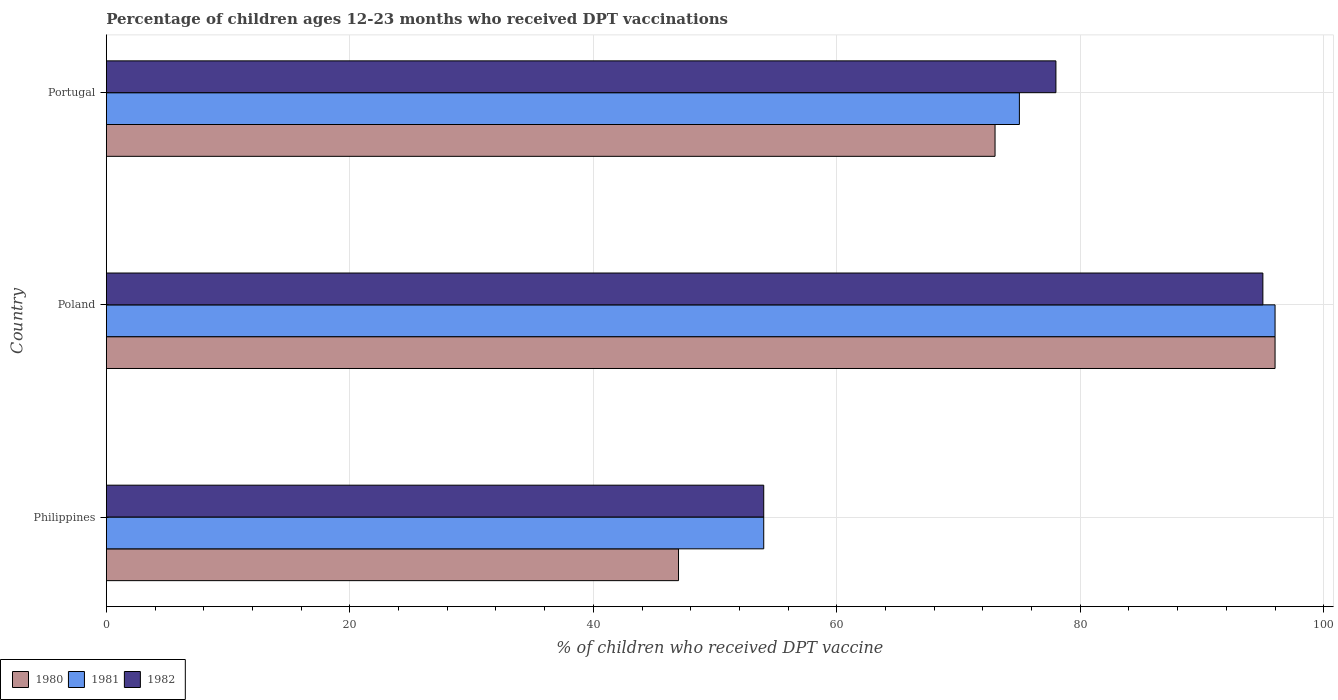Are the number of bars on each tick of the Y-axis equal?
Your answer should be compact. Yes. How many bars are there on the 3rd tick from the top?
Keep it short and to the point. 3. What is the label of the 2nd group of bars from the top?
Your answer should be compact. Poland. What is the percentage of children who received DPT vaccination in 1981 in Philippines?
Your answer should be compact. 54. Across all countries, what is the maximum percentage of children who received DPT vaccination in 1981?
Ensure brevity in your answer.  96. In which country was the percentage of children who received DPT vaccination in 1981 maximum?
Your response must be concise. Poland. In which country was the percentage of children who received DPT vaccination in 1980 minimum?
Ensure brevity in your answer.  Philippines. What is the total percentage of children who received DPT vaccination in 1980 in the graph?
Offer a very short reply. 216. What is the difference between the percentage of children who received DPT vaccination in 1980 in Philippines and that in Poland?
Keep it short and to the point. -49. What is the difference between the percentage of children who received DPT vaccination in 1980 in Poland and the percentage of children who received DPT vaccination in 1981 in Portugal?
Ensure brevity in your answer.  21. What is the difference between the percentage of children who received DPT vaccination in 1980 and percentage of children who received DPT vaccination in 1981 in Philippines?
Offer a very short reply. -7. What is the ratio of the percentage of children who received DPT vaccination in 1980 in Philippines to that in Poland?
Your response must be concise. 0.49. What is the difference between the highest and the lowest percentage of children who received DPT vaccination in 1982?
Provide a short and direct response. 41. Is the sum of the percentage of children who received DPT vaccination in 1982 in Philippines and Portugal greater than the maximum percentage of children who received DPT vaccination in 1980 across all countries?
Offer a very short reply. Yes. Is it the case that in every country, the sum of the percentage of children who received DPT vaccination in 1981 and percentage of children who received DPT vaccination in 1982 is greater than the percentage of children who received DPT vaccination in 1980?
Offer a terse response. Yes. How many countries are there in the graph?
Provide a short and direct response. 3. Are the values on the major ticks of X-axis written in scientific E-notation?
Your answer should be very brief. No. How are the legend labels stacked?
Offer a very short reply. Horizontal. What is the title of the graph?
Ensure brevity in your answer.  Percentage of children ages 12-23 months who received DPT vaccinations. What is the label or title of the X-axis?
Your answer should be compact. % of children who received DPT vaccine. What is the label or title of the Y-axis?
Offer a terse response. Country. What is the % of children who received DPT vaccine of 1980 in Philippines?
Offer a very short reply. 47. What is the % of children who received DPT vaccine in 1982 in Philippines?
Offer a terse response. 54. What is the % of children who received DPT vaccine of 1980 in Poland?
Make the answer very short. 96. What is the % of children who received DPT vaccine of 1981 in Poland?
Your answer should be very brief. 96. What is the % of children who received DPT vaccine in 1980 in Portugal?
Your response must be concise. 73. What is the % of children who received DPT vaccine in 1981 in Portugal?
Ensure brevity in your answer.  75. What is the % of children who received DPT vaccine in 1982 in Portugal?
Your answer should be very brief. 78. Across all countries, what is the maximum % of children who received DPT vaccine of 1980?
Offer a very short reply. 96. Across all countries, what is the maximum % of children who received DPT vaccine of 1981?
Your answer should be compact. 96. Across all countries, what is the maximum % of children who received DPT vaccine of 1982?
Your response must be concise. 95. Across all countries, what is the minimum % of children who received DPT vaccine in 1980?
Make the answer very short. 47. Across all countries, what is the minimum % of children who received DPT vaccine in 1981?
Keep it short and to the point. 54. Across all countries, what is the minimum % of children who received DPT vaccine in 1982?
Ensure brevity in your answer.  54. What is the total % of children who received DPT vaccine in 1980 in the graph?
Your response must be concise. 216. What is the total % of children who received DPT vaccine in 1981 in the graph?
Provide a short and direct response. 225. What is the total % of children who received DPT vaccine in 1982 in the graph?
Offer a terse response. 227. What is the difference between the % of children who received DPT vaccine in 1980 in Philippines and that in Poland?
Provide a succinct answer. -49. What is the difference between the % of children who received DPT vaccine of 1981 in Philippines and that in Poland?
Provide a succinct answer. -42. What is the difference between the % of children who received DPT vaccine of 1982 in Philippines and that in Poland?
Your answer should be compact. -41. What is the difference between the % of children who received DPT vaccine of 1980 in Poland and that in Portugal?
Make the answer very short. 23. What is the difference between the % of children who received DPT vaccine of 1981 in Poland and that in Portugal?
Keep it short and to the point. 21. What is the difference between the % of children who received DPT vaccine of 1980 in Philippines and the % of children who received DPT vaccine of 1981 in Poland?
Provide a succinct answer. -49. What is the difference between the % of children who received DPT vaccine in 1980 in Philippines and the % of children who received DPT vaccine in 1982 in Poland?
Provide a succinct answer. -48. What is the difference between the % of children who received DPT vaccine of 1981 in Philippines and the % of children who received DPT vaccine of 1982 in Poland?
Offer a very short reply. -41. What is the difference between the % of children who received DPT vaccine of 1980 in Philippines and the % of children who received DPT vaccine of 1982 in Portugal?
Provide a succinct answer. -31. What is the difference between the % of children who received DPT vaccine of 1980 in Poland and the % of children who received DPT vaccine of 1982 in Portugal?
Your response must be concise. 18. What is the average % of children who received DPT vaccine in 1982 per country?
Provide a succinct answer. 75.67. What is the difference between the % of children who received DPT vaccine in 1981 and % of children who received DPT vaccine in 1982 in Philippines?
Your response must be concise. 0. What is the difference between the % of children who received DPT vaccine in 1981 and % of children who received DPT vaccine in 1982 in Poland?
Keep it short and to the point. 1. What is the difference between the % of children who received DPT vaccine in 1981 and % of children who received DPT vaccine in 1982 in Portugal?
Give a very brief answer. -3. What is the ratio of the % of children who received DPT vaccine of 1980 in Philippines to that in Poland?
Ensure brevity in your answer.  0.49. What is the ratio of the % of children who received DPT vaccine of 1981 in Philippines to that in Poland?
Your answer should be very brief. 0.56. What is the ratio of the % of children who received DPT vaccine of 1982 in Philippines to that in Poland?
Give a very brief answer. 0.57. What is the ratio of the % of children who received DPT vaccine of 1980 in Philippines to that in Portugal?
Ensure brevity in your answer.  0.64. What is the ratio of the % of children who received DPT vaccine of 1981 in Philippines to that in Portugal?
Offer a terse response. 0.72. What is the ratio of the % of children who received DPT vaccine in 1982 in Philippines to that in Portugal?
Ensure brevity in your answer.  0.69. What is the ratio of the % of children who received DPT vaccine of 1980 in Poland to that in Portugal?
Offer a terse response. 1.32. What is the ratio of the % of children who received DPT vaccine of 1981 in Poland to that in Portugal?
Ensure brevity in your answer.  1.28. What is the ratio of the % of children who received DPT vaccine in 1982 in Poland to that in Portugal?
Your answer should be very brief. 1.22. What is the difference between the highest and the second highest % of children who received DPT vaccine in 1980?
Provide a short and direct response. 23. What is the difference between the highest and the second highest % of children who received DPT vaccine in 1981?
Provide a short and direct response. 21. What is the difference between the highest and the lowest % of children who received DPT vaccine in 1980?
Your answer should be compact. 49. What is the difference between the highest and the lowest % of children who received DPT vaccine of 1982?
Make the answer very short. 41. 